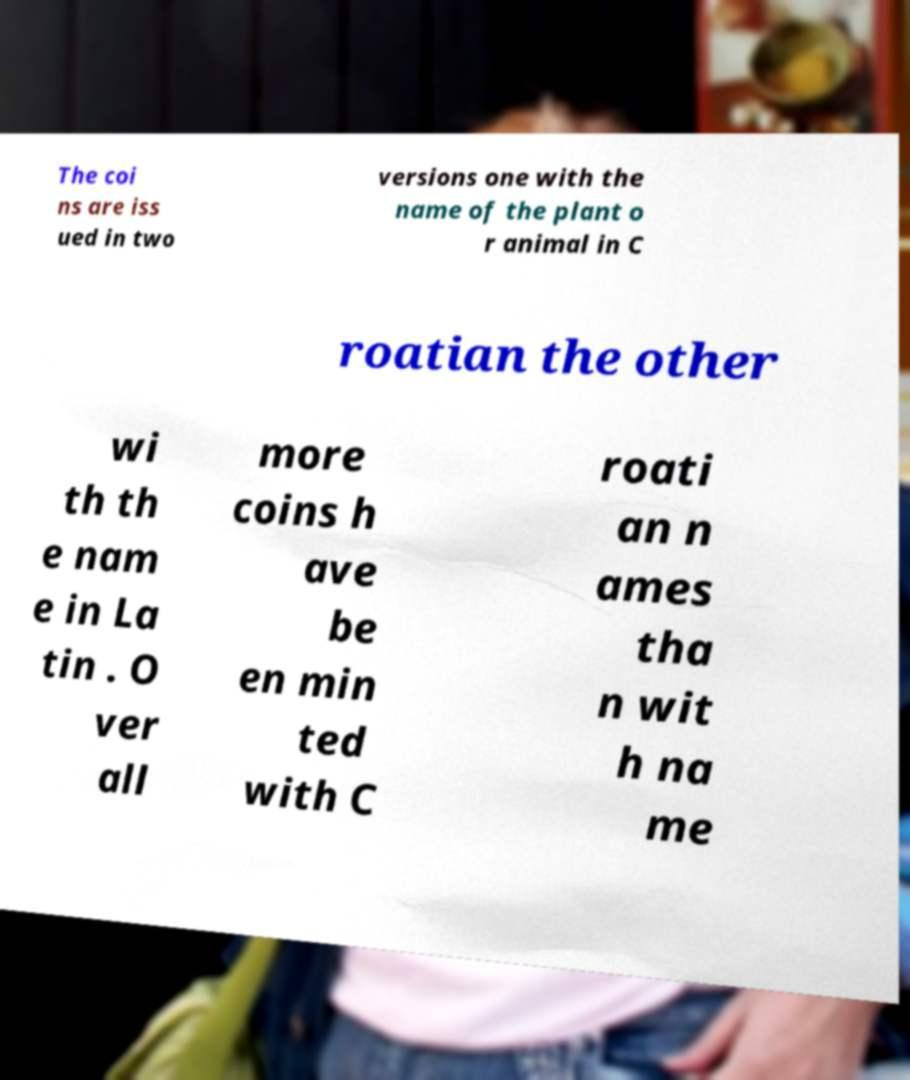Can you accurately transcribe the text from the provided image for me? The coi ns are iss ued in two versions one with the name of the plant o r animal in C roatian the other wi th th e nam e in La tin . O ver all more coins h ave be en min ted with C roati an n ames tha n wit h na me 